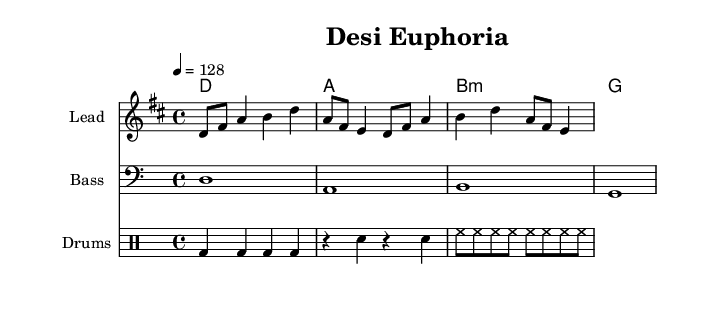What is the key signature of this music? The key signature is D major, which has two sharps: F# and C#. This can be seen in the sheet music's key signature placement, which indicates the tonal center around D.
Answer: D major What is the time signature of this music? The time signature is 4/4, which means there are four beats in each measure and the quarter note gets one beat. This is indicated at the start of the music with the "4/4" notation.
Answer: 4/4 What is the tempo marking for this music? The tempo marking is 128 beats per minute, indicated by the "4 = 128" shown in the tempo section. This specifies how fast the piece should be played.
Answer: 128 How many measures are in the melody? The melody consists of four measures, which can be counted by looking at the number of vertical bar lines in the staff. Each set of notes between the bar lines represents one measure.
Answer: 4 What type of chord is primarily used in the harmony? The primary type of chord used in the harmony is triads; they consist of three notes. Observing the structure of the chords in the harmony section supports this, where each chord is a three-note triad.
Answer: Triads What is the bass clef used in this piece? The bass clef is used for the lower range of music and it signifies that the notes played in this staff are lower in pitch. It is shown as a clef symbol at the beginning of the bass staff.
Answer: Bass clef What type of percussive instrument is indicated for the drum part? The drum part indicates a bass drum, snare drum, and hi-hat. These are specified within the drum notation section, where different symbols represent these percussion instruments.
Answer: Bass drum, snare drum, hi-hat 